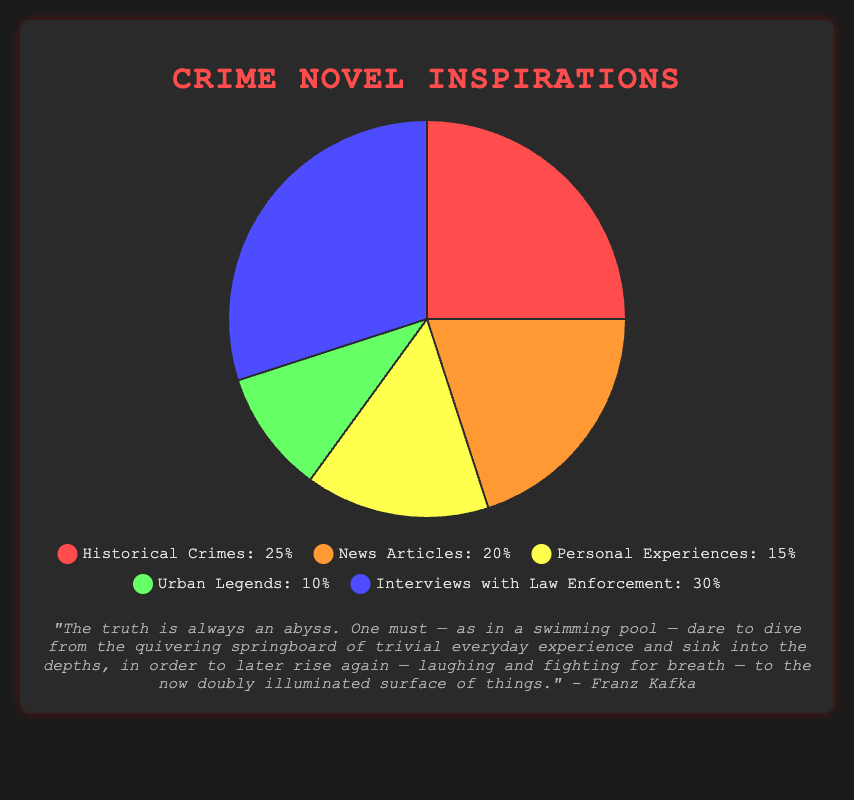Which category has the highest percentage? The figure shows the segments with their respective percentages. The segment labeled "Interviews with Law Enforcement" stands out with the highest percentage, clearly marked at 30%.
Answer: Interviews with Law Enforcement What is the total percentage represented by Historical Crimes and News Articles combined? To find this, you add the percentages of Historical Crimes (25%) and News Articles (20%). The combined total is 25% + 20% = 45%.
Answer: 45% How much larger is the percentage for Interviews with Law Enforcement compared to Urban Legends? The percentage for Interviews with Law Enforcement is 30%, and for Urban Legends, it is 10%. By subtracting, 30% - 10% = 20%, the difference is 20%.
Answer: 20% Which color represents the smallest section of the pie chart? By inspecting the visual attributes, the segment corresponding to Urban Legends is marked with a green color and represents 10%, making it the smallest section.
Answer: green What is the average percentage of all the inspirations? Sum all percentages: 25% + 20% + 15% + 10% + 30% = 100%. Then, divide by the number of categories which is 5. So, the average is 100% / 5 = 20%.
Answer: 20% Are Historical Crimes and Personal Experiences collectively more than 40%? The percentage for Historical Crimes is 25% and for Personal Experiences is 15%. Adding them gives 25% + 15% = 40%. They are not collectively more than 40%, but exactly 40%.
Answer: no Which inspiration sources have a higher percentage than the average percentage? The average percentage is 20%. By comparing each source, Interviews with Law Enforcement (30%) and Historical Crimes (25%) are higher than 20%.
Answer: Interviews with Law Enforcement and Historical Crimes Of the five categories, which one is represented by the blue color, and what is its percentage? The blue color represents Interviews with Law Enforcement, which has a percentage of 30%.
Answer: Interviews with Law Enforcement, 30% 